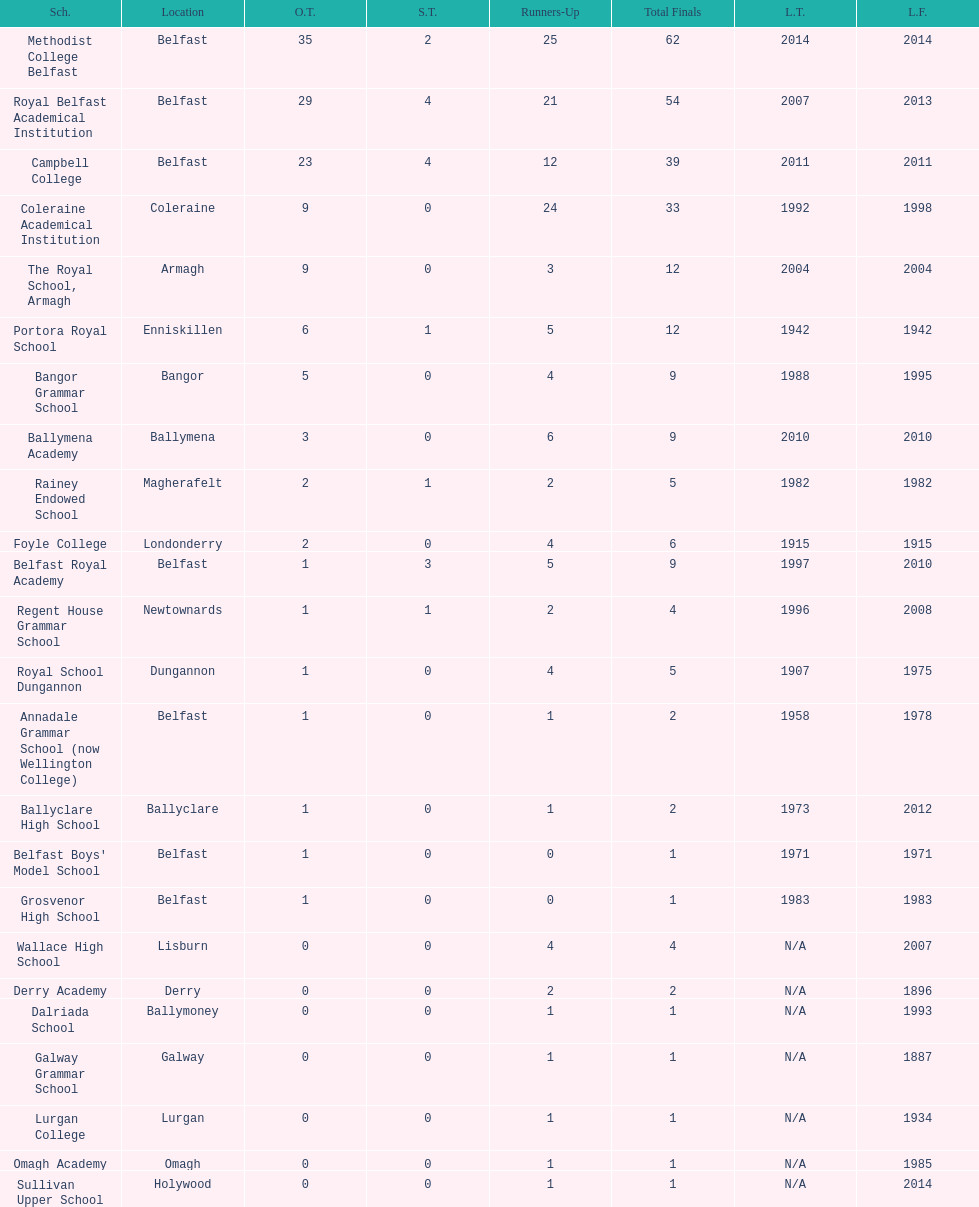Which two schools each had twelve total finals? The Royal School, Armagh, Portora Royal School. 